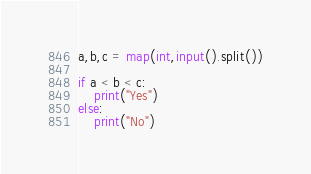Convert code to text. <code><loc_0><loc_0><loc_500><loc_500><_Python_>a,b,c = map(int,input().split())

if a < b < c:
    print("Yes")
else:
    print("No")
</code> 